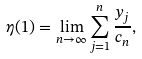<formula> <loc_0><loc_0><loc_500><loc_500>\eta ( 1 ) = \lim _ { n \to \infty } \sum _ { j = 1 } ^ { n } \frac { y _ { j } } { c _ { n } } ,</formula> 